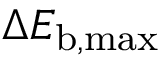Convert formula to latex. <formula><loc_0><loc_0><loc_500><loc_500>\Delta E _ { b , \max }</formula> 